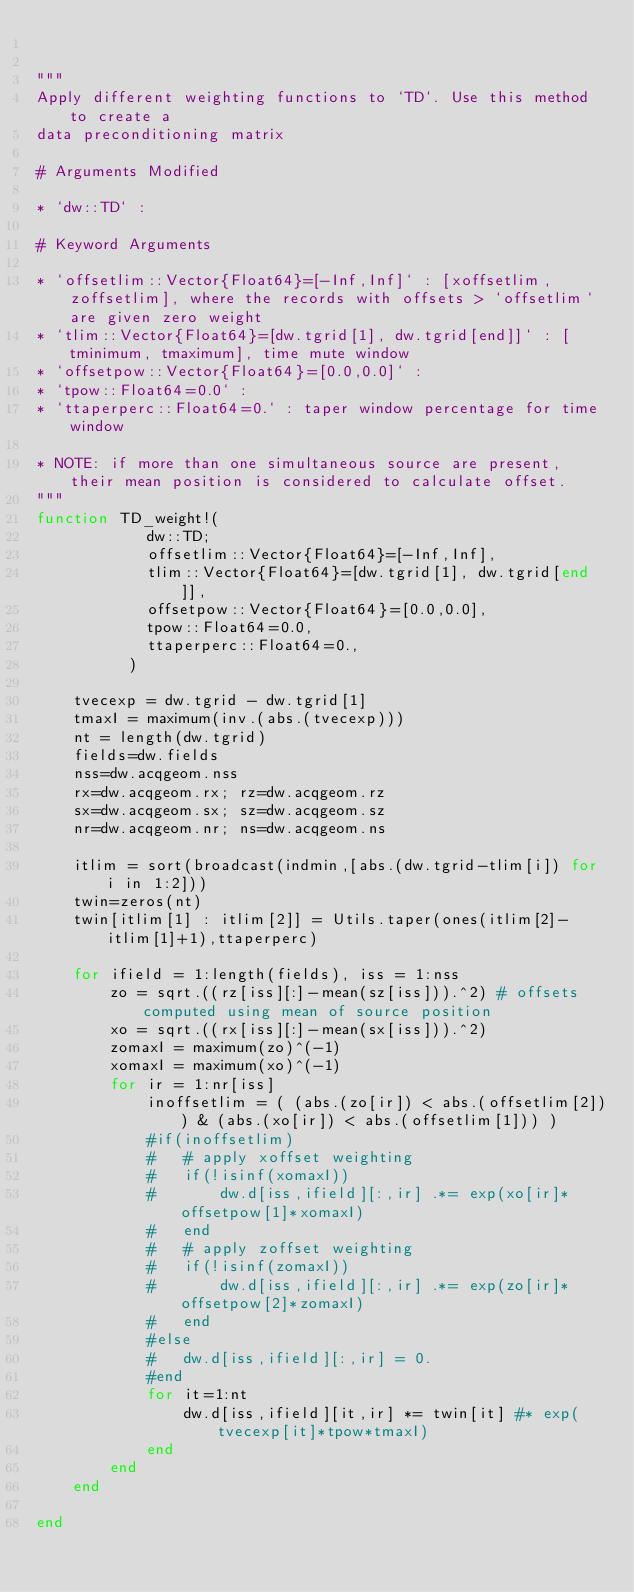<code> <loc_0><loc_0><loc_500><loc_500><_Julia_>

"""
Apply different weighting functions to `TD`. Use this method to create a 
data preconditioning matrix

# Arguments Modified

* `dw::TD` : 

# Keyword Arguments

* `offsetlim::Vector{Float64}=[-Inf,Inf]` : [xoffsetlim, zoffsetlim], where the records with offsets > `offsetlim` are given zero weight 
* `tlim::Vector{Float64}=[dw.tgrid[1], dw.tgrid[end]]` : [tminimum, tmaximum], time mute window 
* `offsetpow::Vector{Float64}=[0.0,0.0]` : 
* `tpow::Float64=0.0` :
* `ttaperperc::Float64=0.` : taper window percentage for time window

* NOTE: if more than one simultaneous source are present, their mean position is considered to calculate offset.
"""
function TD_weight!(
		    dw::TD;
		    offsetlim::Vector{Float64}=[-Inf,Inf],
		    tlim::Vector{Float64}=[dw.tgrid[1], dw.tgrid[end]],
		    offsetpow::Vector{Float64}=[0.0,0.0],
		    tpow::Float64=0.0,
		    ttaperperc::Float64=0.,
		  )

	tvecexp = dw.tgrid - dw.tgrid[1]
	tmaxI = maximum(inv.(abs.(tvecexp)))
	nt = length(dw.tgrid)
	fields=dw.fields
	nss=dw.acqgeom.nss
	rx=dw.acqgeom.rx; rz=dw.acqgeom.rz
	sx=dw.acqgeom.sx; sz=dw.acqgeom.sz
	nr=dw.acqgeom.nr; ns=dw.acqgeom.ns

	itlim = sort(broadcast(indmin,[abs.(dw.tgrid-tlim[i]) for i in 1:2]))
	twin=zeros(nt)
	twin[itlim[1] : itlim[2]] = Utils.taper(ones(itlim[2]-itlim[1]+1),ttaperperc) 

	for ifield = 1:length(fields), iss = 1:nss
		zo = sqrt.((rz[iss][:]-mean(sz[iss])).^2) # offsets computed using mean of source position
		xo = sqrt.((rx[iss][:]-mean(sx[iss])).^2)
		zomaxI = maximum(zo)^(-1)
		xomaxI = maximum(xo)^(-1)
		for ir = 1:nr[iss]
			inoffsetlim = ( (abs.(zo[ir]) < abs.(offsetlim[2])) & (abs.(xo[ir]) < abs.(offsetlim[1])) )
			#if(inoffsetlim)
			#	# apply xoffset weighting 
			#	if(!isinf(xomaxI))
			#		dw.d[iss,ifield][:,ir] .*= exp(xo[ir]*offsetpow[1]*xomaxI) 
			#	end
			#	# apply zoffset weighting
			#	if(!isinf(zomaxI))
			#		dw.d[iss,ifield][:,ir] .*= exp(zo[ir]*offsetpow[2]*zomaxI)
			#	end
			#else
			#	dw.d[iss,ifield][:,ir] = 0.
			#end
			for it=1:nt
				dw.d[iss,ifield][it,ir] *= twin[it] #* exp(tvecexp[it]*tpow*tmaxI)
			end
		end
	end

end


</code> 